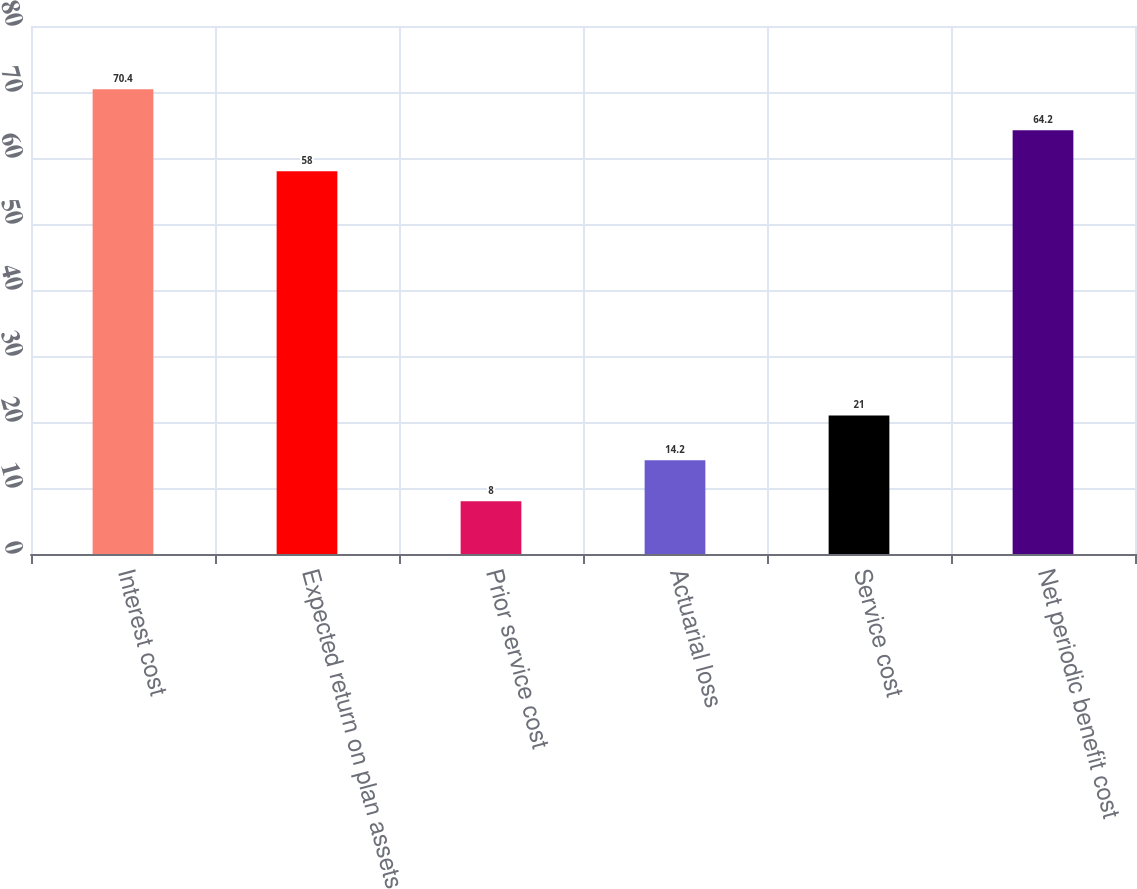<chart> <loc_0><loc_0><loc_500><loc_500><bar_chart><fcel>Interest cost<fcel>Expected return on plan assets<fcel>Prior service cost<fcel>Actuarial loss<fcel>Service cost<fcel>Net periodic benefit cost<nl><fcel>70.4<fcel>58<fcel>8<fcel>14.2<fcel>21<fcel>64.2<nl></chart> 